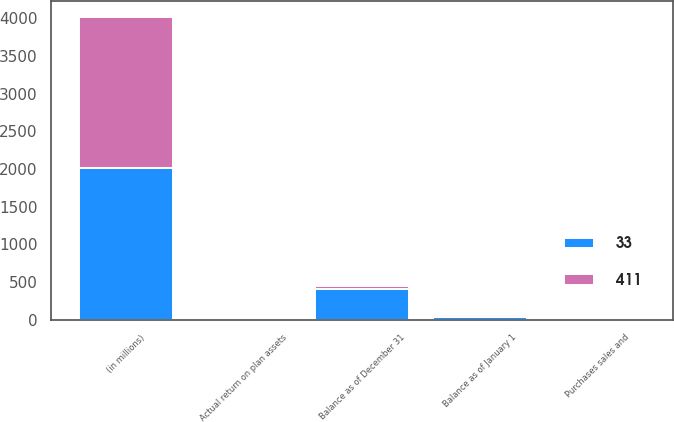<chart> <loc_0><loc_0><loc_500><loc_500><stacked_bar_chart><ecel><fcel>(in millions)<fcel>Balance as of January 1<fcel>Actual return on plan assets<fcel>Purchases sales and<fcel>Balance as of December 31<nl><fcel>33<fcel>2013<fcel>33<fcel>4<fcel>2<fcel>411<nl><fcel>411<fcel>2012<fcel>27<fcel>3<fcel>3<fcel>33<nl></chart> 